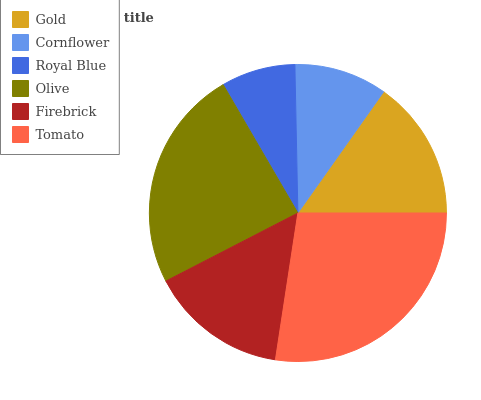Is Royal Blue the minimum?
Answer yes or no. Yes. Is Tomato the maximum?
Answer yes or no. Yes. Is Cornflower the minimum?
Answer yes or no. No. Is Cornflower the maximum?
Answer yes or no. No. Is Gold greater than Cornflower?
Answer yes or no. Yes. Is Cornflower less than Gold?
Answer yes or no. Yes. Is Cornflower greater than Gold?
Answer yes or no. No. Is Gold less than Cornflower?
Answer yes or no. No. Is Gold the high median?
Answer yes or no. Yes. Is Firebrick the low median?
Answer yes or no. Yes. Is Tomato the high median?
Answer yes or no. No. Is Cornflower the low median?
Answer yes or no. No. 